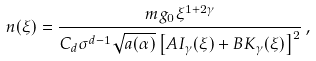Convert formula to latex. <formula><loc_0><loc_0><loc_500><loc_500>n ( \xi ) = \frac { m g _ { 0 } \xi ^ { 1 + 2 \gamma } } { C _ { d } \sigma ^ { d - 1 } \sqrt { a ( \alpha ) } \left [ A I _ { \gamma } ( \xi ) + B K _ { \gamma } ( \xi ) \right ] ^ { 2 } } \, ,</formula> 